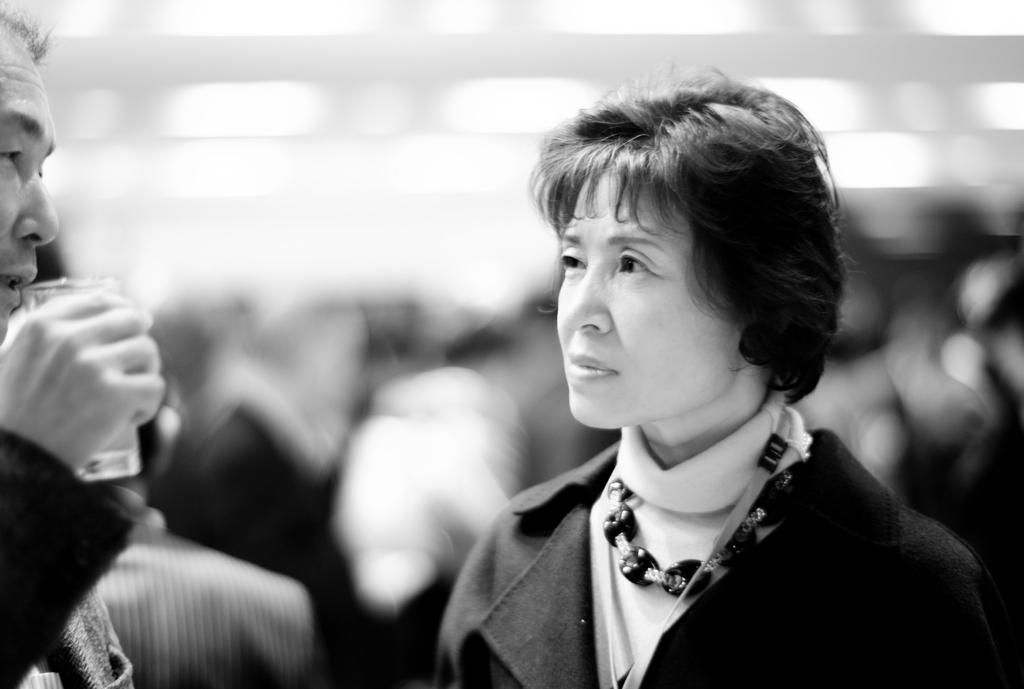What is the color scheme of the image? The image is black and white. What can be seen on the floor in the image? There are people standing on the floor in the image. What type of bun is being served to the people in the image? There is no bun present in the image. What pet can be seen accompanying the people in the image? There is no pet visible in the image. 